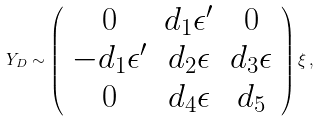Convert formula to latex. <formula><loc_0><loc_0><loc_500><loc_500>Y _ { D } \sim \left ( \begin{array} { c c c } 0 & d _ { 1 } \epsilon ^ { \prime } & 0 \\ - d _ { 1 } \epsilon ^ { \prime } & d _ { 2 } \epsilon & d _ { 3 } \epsilon \\ 0 & d _ { 4 } \epsilon & d _ { 5 } \end{array} \right ) \xi \, ,</formula> 